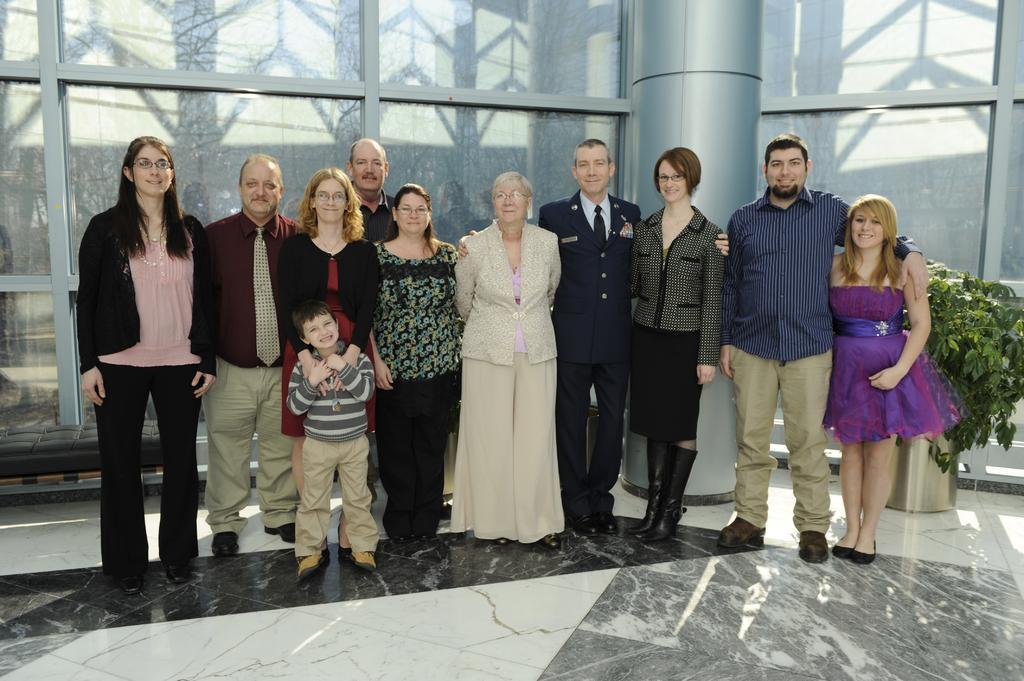Describe this image in one or two sentences. In this image we can see people standing on the floor. In the background of the image there is a glass wall, pillar and plant. 